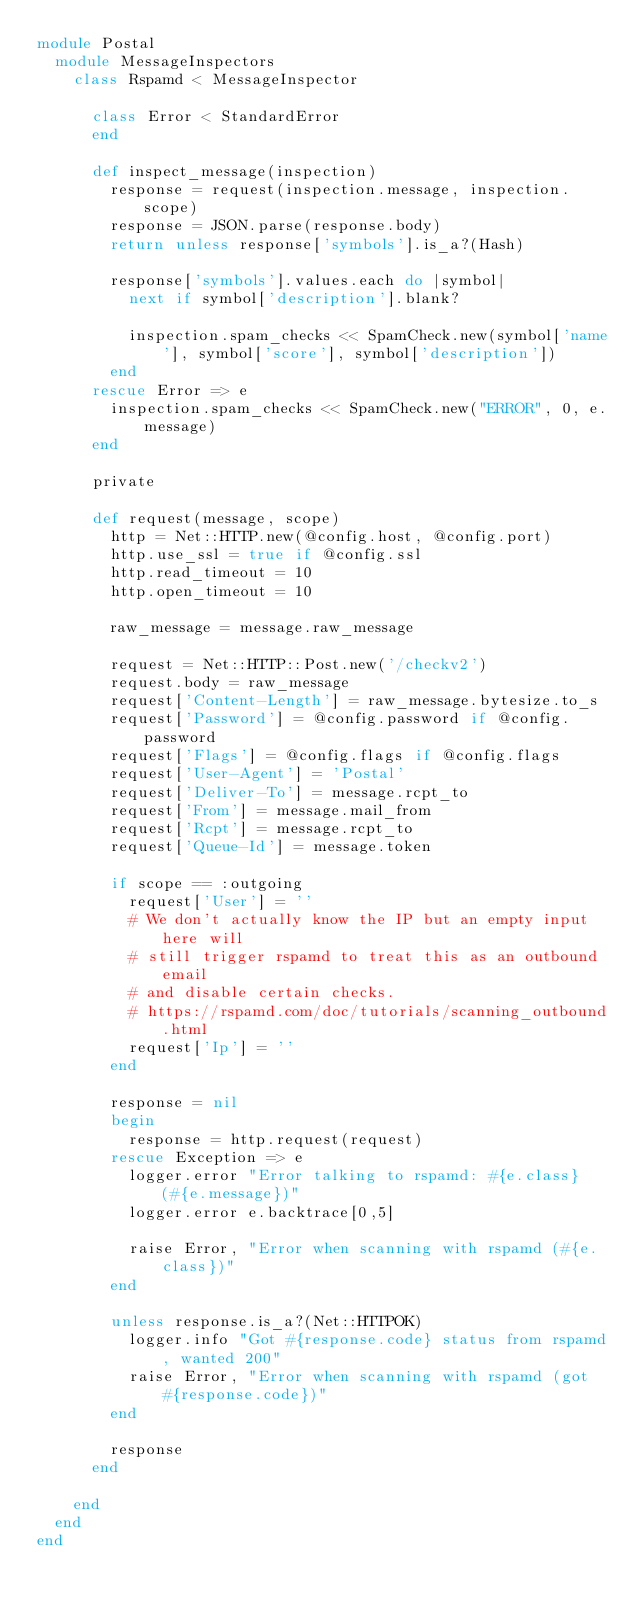Convert code to text. <code><loc_0><loc_0><loc_500><loc_500><_Ruby_>module Postal
  module MessageInspectors
    class Rspamd < MessageInspector

      class Error < StandardError
      end

      def inspect_message(inspection)
        response = request(inspection.message, inspection.scope)
        response = JSON.parse(response.body)
        return unless response['symbols'].is_a?(Hash)

        response['symbols'].values.each do |symbol|
          next if symbol['description'].blank?

          inspection.spam_checks << SpamCheck.new(symbol['name'], symbol['score'], symbol['description'])
        end
      rescue Error => e
        inspection.spam_checks << SpamCheck.new("ERROR", 0, e.message)
      end

      private

      def request(message, scope)
        http = Net::HTTP.new(@config.host, @config.port)
        http.use_ssl = true if @config.ssl
        http.read_timeout = 10
        http.open_timeout = 10

        raw_message = message.raw_message

        request = Net::HTTP::Post.new('/checkv2')
        request.body = raw_message
        request['Content-Length'] = raw_message.bytesize.to_s
        request['Password'] = @config.password if @config.password
        request['Flags'] = @config.flags if @config.flags
        request['User-Agent'] = 'Postal'
        request['Deliver-To'] = message.rcpt_to
        request['From'] = message.mail_from
        request['Rcpt'] = message.rcpt_to
        request['Queue-Id'] = message.token

        if scope == :outgoing
          request['User'] = ''
          # We don't actually know the IP but an empty input here will
          # still trigger rspamd to treat this as an outbound email
          # and disable certain checks.
          # https://rspamd.com/doc/tutorials/scanning_outbound.html
          request['Ip'] = ''
        end

        response = nil
        begin
          response = http.request(request)
        rescue Exception => e
          logger.error "Error talking to rspamd: #{e.class} (#{e.message})"
          logger.error e.backtrace[0,5]

          raise Error, "Error when scanning with rspamd (#{e.class})"
        end

        unless response.is_a?(Net::HTTPOK)
          logger.info "Got #{response.code} status from rspamd, wanted 200"
          raise Error, "Error when scanning with rspamd (got #{response.code})"
        end

        response
      end

    end
  end
end
</code> 